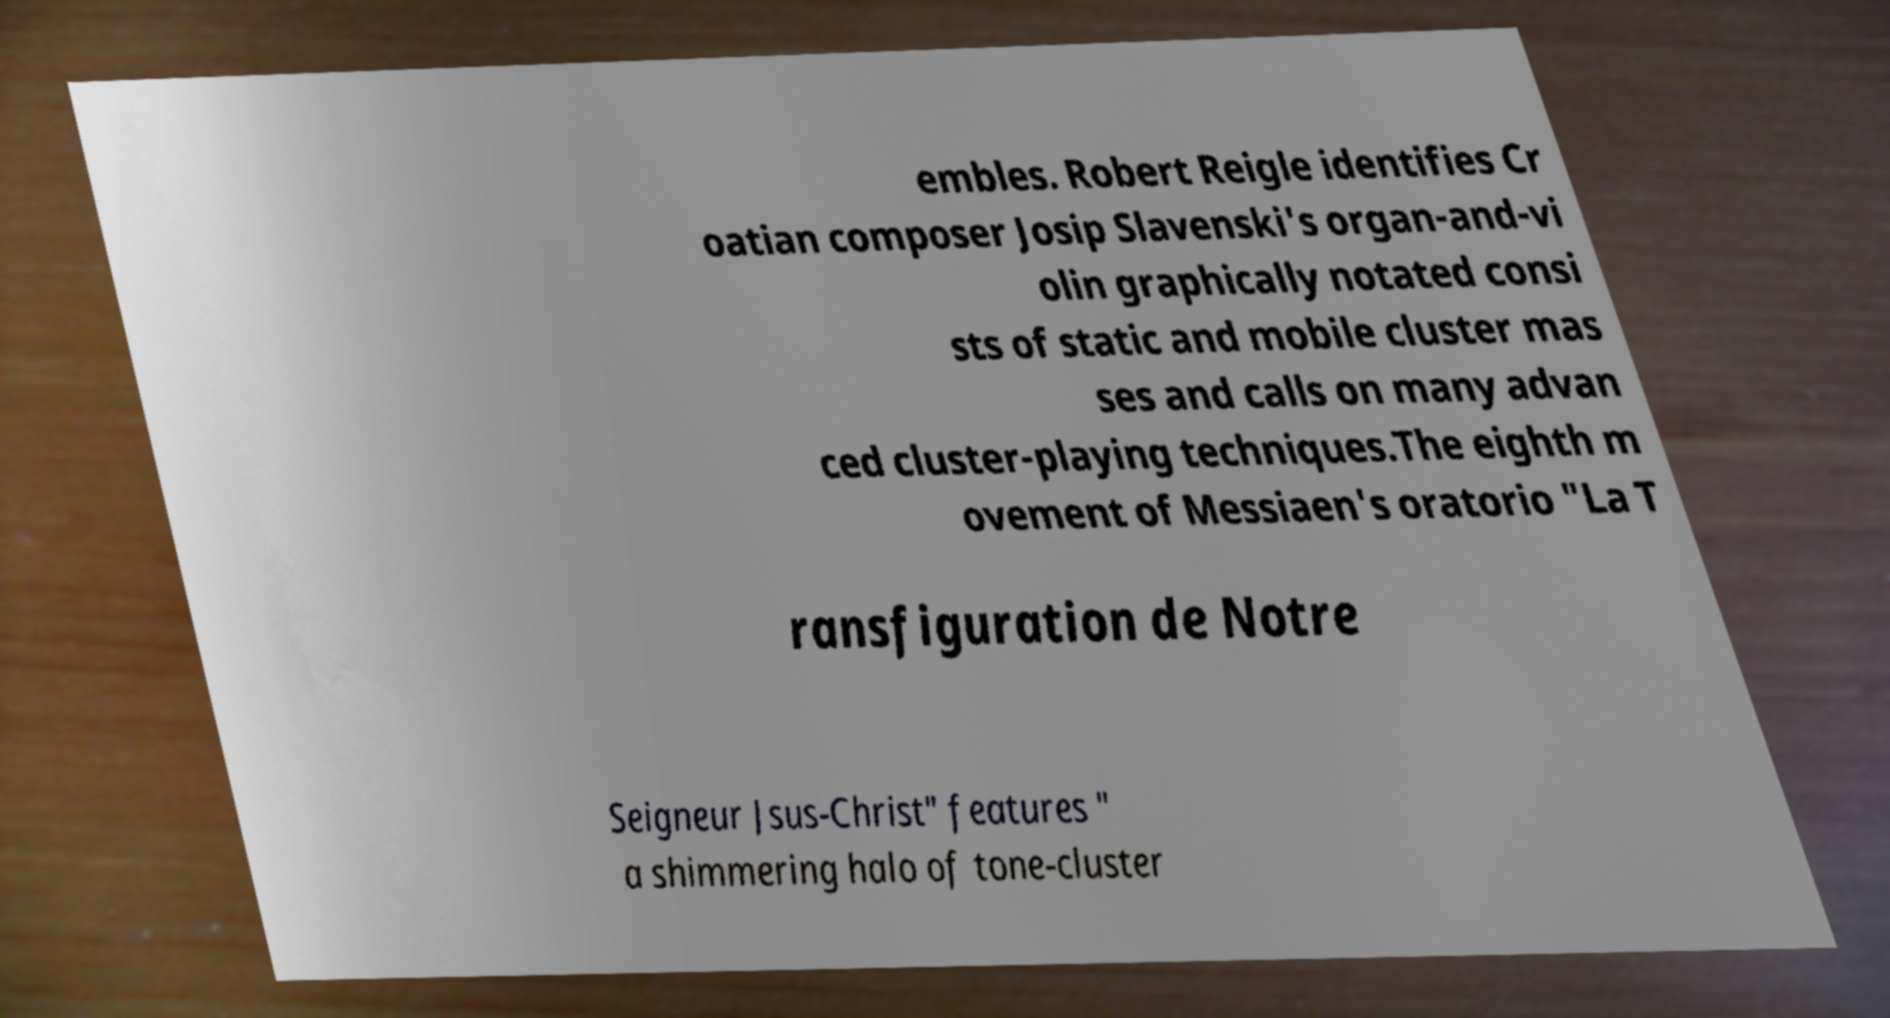Please read and relay the text visible in this image. What does it say? embles. Robert Reigle identifies Cr oatian composer Josip Slavenski's organ-and-vi olin graphically notated consi sts of static and mobile cluster mas ses and calls on many advan ced cluster-playing techniques.The eighth m ovement of Messiaen's oratorio "La T ransfiguration de Notre Seigneur Jsus-Christ" features " a shimmering halo of tone-cluster 